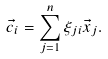<formula> <loc_0><loc_0><loc_500><loc_500>\vec { c } _ { i } = \sum _ { j = 1 } ^ { n } \xi _ { j i } \vec { x } _ { j } .</formula> 